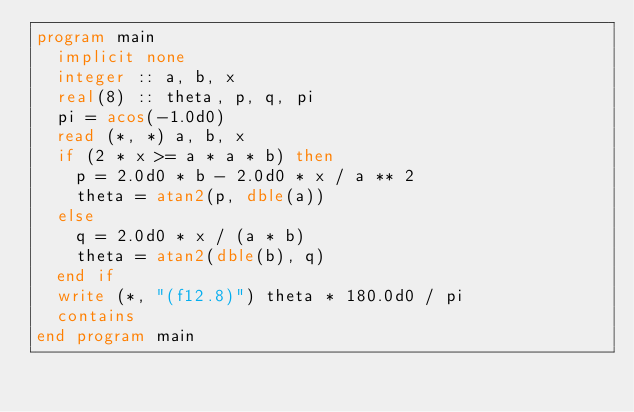<code> <loc_0><loc_0><loc_500><loc_500><_FORTRAN_>program main
  implicit none
  integer :: a, b, x
  real(8) :: theta, p, q, pi
  pi = acos(-1.0d0)
  read (*, *) a, b, x
  if (2 * x >= a * a * b) then
    p = 2.0d0 * b - 2.0d0 * x / a ** 2
    theta = atan2(p, dble(a))
  else
    q = 2.0d0 * x / (a * b)
    theta = atan2(dble(b), q)
  end if
  write (*, "(f12.8)") theta * 180.0d0 / pi
  contains
end program main
</code> 